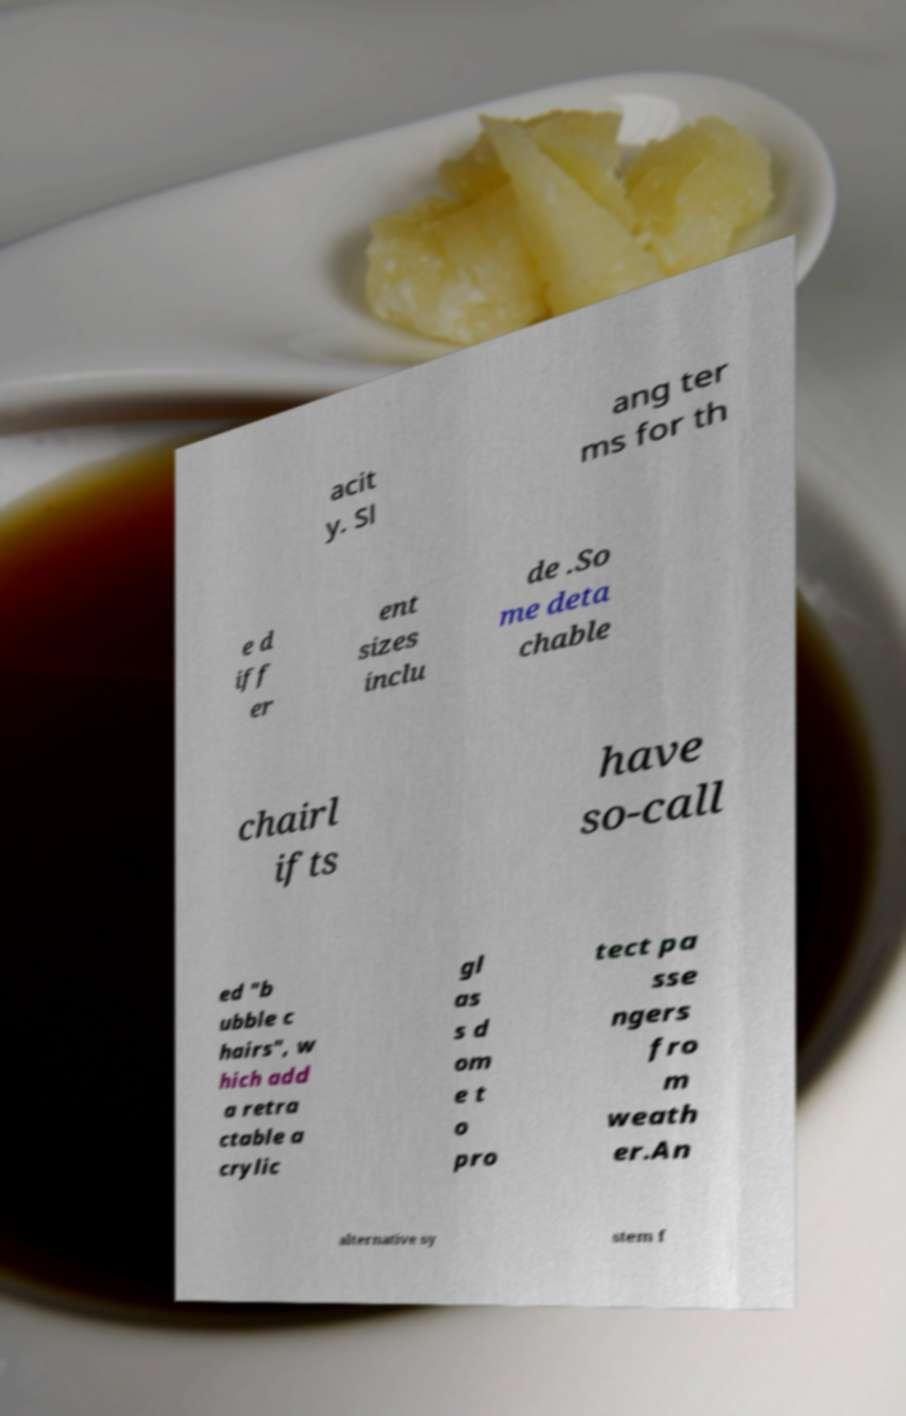Could you assist in decoding the text presented in this image and type it out clearly? acit y. Sl ang ter ms for th e d iff er ent sizes inclu de .So me deta chable chairl ifts have so-call ed "b ubble c hairs", w hich add a retra ctable a crylic gl as s d om e t o pro tect pa sse ngers fro m weath er.An alternative sy stem f 